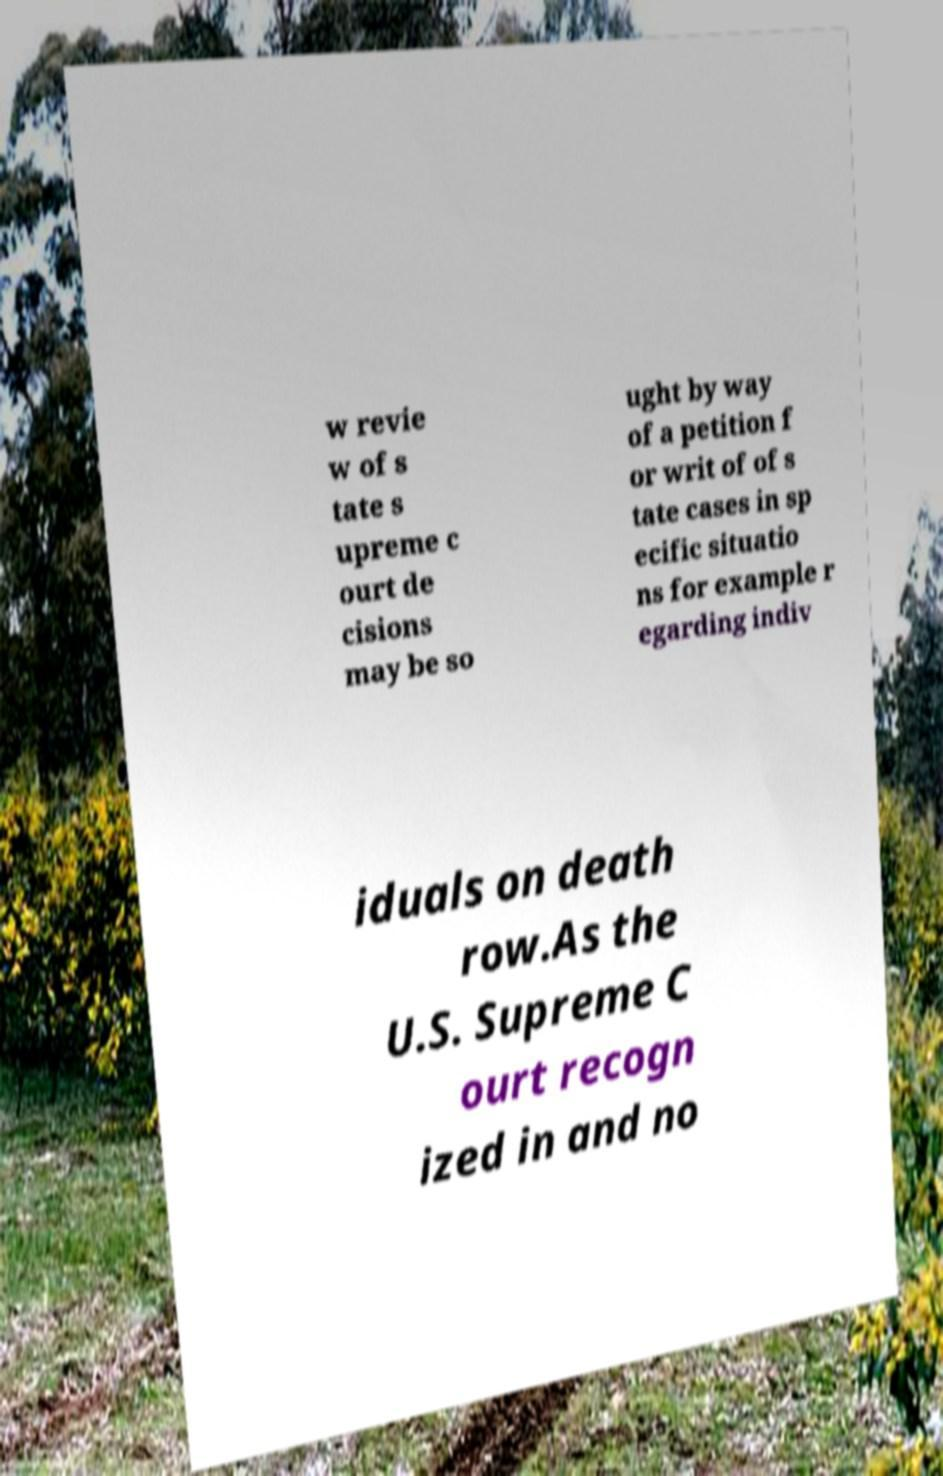Can you accurately transcribe the text from the provided image for me? w revie w of s tate s upreme c ourt de cisions may be so ught by way of a petition f or writ of of s tate cases in sp ecific situatio ns for example r egarding indiv iduals on death row.As the U.S. Supreme C ourt recogn ized in and no 